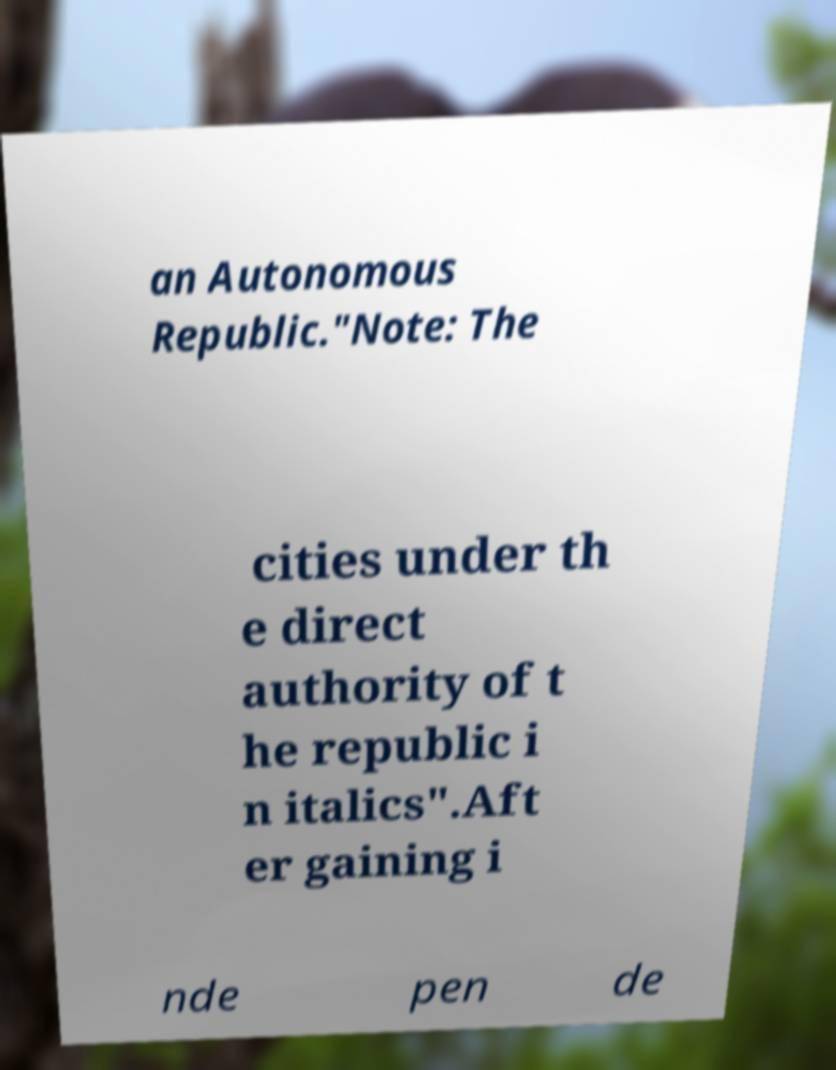For documentation purposes, I need the text within this image transcribed. Could you provide that? an Autonomous Republic."Note: The cities under th e direct authority of t he republic i n italics".Aft er gaining i nde pen de 